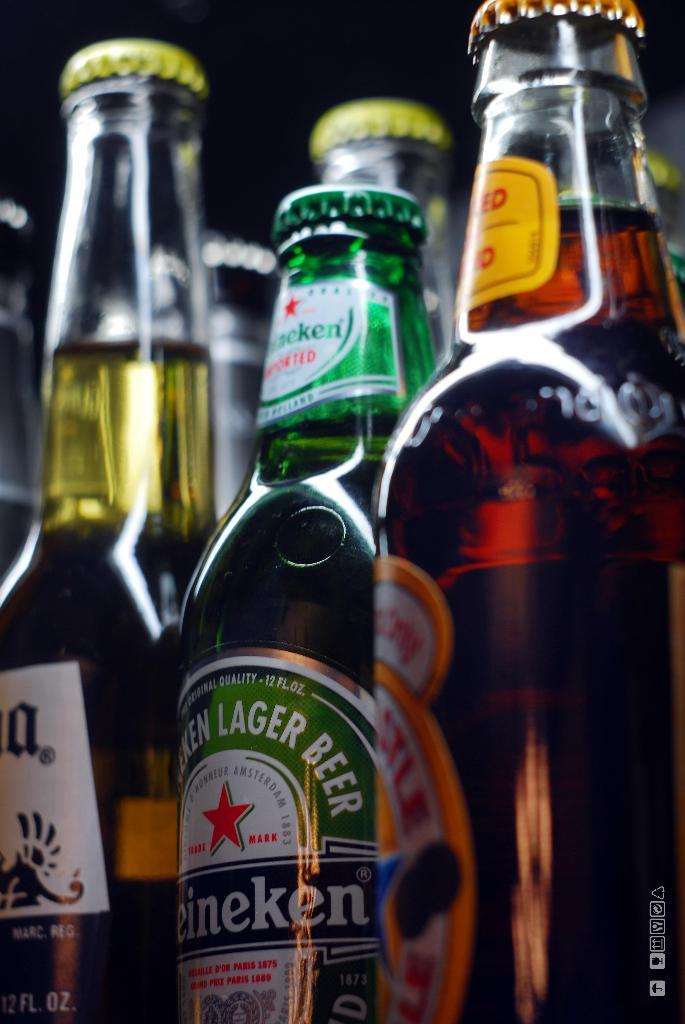<image>
Relay a brief, clear account of the picture shown. A row of unopened beer bottles including Heineken. 